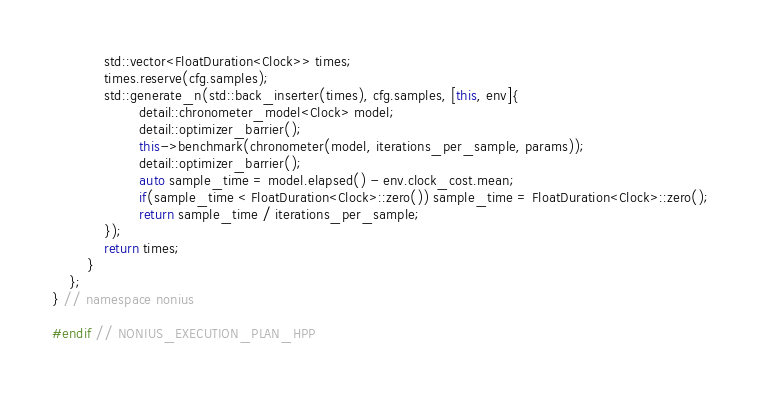Convert code to text. <code><loc_0><loc_0><loc_500><loc_500><_C++_>            std::vector<FloatDuration<Clock>> times;
            times.reserve(cfg.samples);
            std::generate_n(std::back_inserter(times), cfg.samples, [this, env]{
                    detail::chronometer_model<Clock> model;
                    detail::optimizer_barrier();
                    this->benchmark(chronometer(model, iterations_per_sample, params));
                    detail::optimizer_barrier();
                    auto sample_time = model.elapsed() - env.clock_cost.mean;
                    if(sample_time < FloatDuration<Clock>::zero()) sample_time = FloatDuration<Clock>::zero();
                    return sample_time / iterations_per_sample;
            });
            return times;
        }
    };
} // namespace nonius

#endif // NONIUS_EXECUTION_PLAN_HPP
</code> 